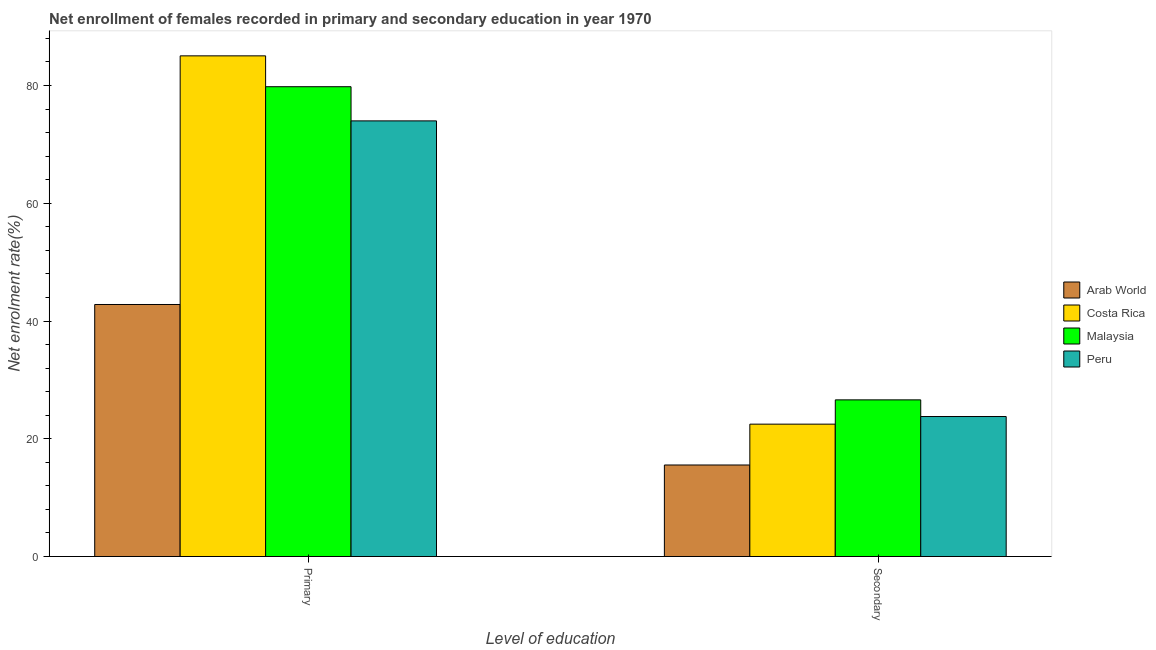How many different coloured bars are there?
Provide a short and direct response. 4. How many groups of bars are there?
Make the answer very short. 2. Are the number of bars per tick equal to the number of legend labels?
Offer a very short reply. Yes. Are the number of bars on each tick of the X-axis equal?
Keep it short and to the point. Yes. How many bars are there on the 2nd tick from the left?
Provide a succinct answer. 4. How many bars are there on the 2nd tick from the right?
Keep it short and to the point. 4. What is the label of the 2nd group of bars from the left?
Your answer should be compact. Secondary. What is the enrollment rate in secondary education in Peru?
Offer a very short reply. 23.78. Across all countries, what is the maximum enrollment rate in primary education?
Keep it short and to the point. 85.03. Across all countries, what is the minimum enrollment rate in primary education?
Keep it short and to the point. 42.8. In which country was the enrollment rate in secondary education maximum?
Keep it short and to the point. Malaysia. In which country was the enrollment rate in primary education minimum?
Offer a very short reply. Arab World. What is the total enrollment rate in secondary education in the graph?
Offer a terse response. 88.41. What is the difference between the enrollment rate in primary education in Peru and that in Malaysia?
Keep it short and to the point. -5.8. What is the difference between the enrollment rate in primary education in Malaysia and the enrollment rate in secondary education in Peru?
Your answer should be compact. 56.01. What is the average enrollment rate in secondary education per country?
Provide a succinct answer. 22.1. What is the difference between the enrollment rate in primary education and enrollment rate in secondary education in Costa Rica?
Your response must be concise. 62.55. In how many countries, is the enrollment rate in primary education greater than 8 %?
Provide a short and direct response. 4. What is the ratio of the enrollment rate in primary education in Malaysia to that in Arab World?
Your answer should be very brief. 1.86. Is the enrollment rate in secondary education in Malaysia less than that in Arab World?
Make the answer very short. No. What does the 2nd bar from the right in Secondary represents?
Your answer should be compact. Malaysia. Does the graph contain any zero values?
Make the answer very short. No. How many legend labels are there?
Make the answer very short. 4. What is the title of the graph?
Your answer should be compact. Net enrollment of females recorded in primary and secondary education in year 1970. Does "Andorra" appear as one of the legend labels in the graph?
Make the answer very short. No. What is the label or title of the X-axis?
Your answer should be compact. Level of education. What is the label or title of the Y-axis?
Provide a short and direct response. Net enrolment rate(%). What is the Net enrolment rate(%) in Arab World in Primary?
Your response must be concise. 42.8. What is the Net enrolment rate(%) of Costa Rica in Primary?
Your answer should be very brief. 85.03. What is the Net enrolment rate(%) in Malaysia in Primary?
Make the answer very short. 79.79. What is the Net enrolment rate(%) of Peru in Primary?
Your answer should be very brief. 73.99. What is the Net enrolment rate(%) in Arab World in Secondary?
Give a very brief answer. 15.54. What is the Net enrolment rate(%) of Costa Rica in Secondary?
Your response must be concise. 22.48. What is the Net enrolment rate(%) of Malaysia in Secondary?
Provide a succinct answer. 26.61. What is the Net enrolment rate(%) in Peru in Secondary?
Offer a very short reply. 23.78. Across all Level of education, what is the maximum Net enrolment rate(%) of Arab World?
Offer a terse response. 42.8. Across all Level of education, what is the maximum Net enrolment rate(%) of Costa Rica?
Your answer should be very brief. 85.03. Across all Level of education, what is the maximum Net enrolment rate(%) of Malaysia?
Provide a succinct answer. 79.79. Across all Level of education, what is the maximum Net enrolment rate(%) of Peru?
Your response must be concise. 73.99. Across all Level of education, what is the minimum Net enrolment rate(%) of Arab World?
Offer a terse response. 15.54. Across all Level of education, what is the minimum Net enrolment rate(%) of Costa Rica?
Your response must be concise. 22.48. Across all Level of education, what is the minimum Net enrolment rate(%) of Malaysia?
Make the answer very short. 26.61. Across all Level of education, what is the minimum Net enrolment rate(%) in Peru?
Give a very brief answer. 23.78. What is the total Net enrolment rate(%) in Arab World in the graph?
Keep it short and to the point. 58.35. What is the total Net enrolment rate(%) of Costa Rica in the graph?
Give a very brief answer. 107.51. What is the total Net enrolment rate(%) in Malaysia in the graph?
Give a very brief answer. 106.4. What is the total Net enrolment rate(%) in Peru in the graph?
Keep it short and to the point. 97.77. What is the difference between the Net enrolment rate(%) in Arab World in Primary and that in Secondary?
Provide a short and direct response. 27.26. What is the difference between the Net enrolment rate(%) of Costa Rica in Primary and that in Secondary?
Your response must be concise. 62.55. What is the difference between the Net enrolment rate(%) of Malaysia in Primary and that in Secondary?
Your answer should be compact. 53.18. What is the difference between the Net enrolment rate(%) of Peru in Primary and that in Secondary?
Your answer should be compact. 50.21. What is the difference between the Net enrolment rate(%) in Arab World in Primary and the Net enrolment rate(%) in Costa Rica in Secondary?
Offer a terse response. 20.32. What is the difference between the Net enrolment rate(%) of Arab World in Primary and the Net enrolment rate(%) of Malaysia in Secondary?
Give a very brief answer. 16.2. What is the difference between the Net enrolment rate(%) of Arab World in Primary and the Net enrolment rate(%) of Peru in Secondary?
Provide a short and direct response. 19.03. What is the difference between the Net enrolment rate(%) in Costa Rica in Primary and the Net enrolment rate(%) in Malaysia in Secondary?
Ensure brevity in your answer.  58.42. What is the difference between the Net enrolment rate(%) of Costa Rica in Primary and the Net enrolment rate(%) of Peru in Secondary?
Give a very brief answer. 61.25. What is the difference between the Net enrolment rate(%) in Malaysia in Primary and the Net enrolment rate(%) in Peru in Secondary?
Ensure brevity in your answer.  56.01. What is the average Net enrolment rate(%) of Arab World per Level of education?
Your answer should be very brief. 29.17. What is the average Net enrolment rate(%) in Costa Rica per Level of education?
Provide a short and direct response. 53.76. What is the average Net enrolment rate(%) of Malaysia per Level of education?
Make the answer very short. 53.2. What is the average Net enrolment rate(%) in Peru per Level of education?
Offer a very short reply. 48.88. What is the difference between the Net enrolment rate(%) in Arab World and Net enrolment rate(%) in Costa Rica in Primary?
Give a very brief answer. -42.23. What is the difference between the Net enrolment rate(%) in Arab World and Net enrolment rate(%) in Malaysia in Primary?
Your answer should be compact. -36.99. What is the difference between the Net enrolment rate(%) in Arab World and Net enrolment rate(%) in Peru in Primary?
Offer a terse response. -31.18. What is the difference between the Net enrolment rate(%) in Costa Rica and Net enrolment rate(%) in Malaysia in Primary?
Ensure brevity in your answer.  5.24. What is the difference between the Net enrolment rate(%) in Costa Rica and Net enrolment rate(%) in Peru in Primary?
Your answer should be very brief. 11.04. What is the difference between the Net enrolment rate(%) of Malaysia and Net enrolment rate(%) of Peru in Primary?
Ensure brevity in your answer.  5.8. What is the difference between the Net enrolment rate(%) of Arab World and Net enrolment rate(%) of Costa Rica in Secondary?
Offer a very short reply. -6.94. What is the difference between the Net enrolment rate(%) of Arab World and Net enrolment rate(%) of Malaysia in Secondary?
Your answer should be very brief. -11.06. What is the difference between the Net enrolment rate(%) of Arab World and Net enrolment rate(%) of Peru in Secondary?
Your response must be concise. -8.23. What is the difference between the Net enrolment rate(%) in Costa Rica and Net enrolment rate(%) in Malaysia in Secondary?
Your answer should be compact. -4.12. What is the difference between the Net enrolment rate(%) in Costa Rica and Net enrolment rate(%) in Peru in Secondary?
Your response must be concise. -1.3. What is the difference between the Net enrolment rate(%) in Malaysia and Net enrolment rate(%) in Peru in Secondary?
Offer a very short reply. 2.83. What is the ratio of the Net enrolment rate(%) in Arab World in Primary to that in Secondary?
Your answer should be very brief. 2.75. What is the ratio of the Net enrolment rate(%) of Costa Rica in Primary to that in Secondary?
Keep it short and to the point. 3.78. What is the ratio of the Net enrolment rate(%) in Malaysia in Primary to that in Secondary?
Make the answer very short. 3. What is the ratio of the Net enrolment rate(%) of Peru in Primary to that in Secondary?
Give a very brief answer. 3.11. What is the difference between the highest and the second highest Net enrolment rate(%) in Arab World?
Give a very brief answer. 27.26. What is the difference between the highest and the second highest Net enrolment rate(%) of Costa Rica?
Give a very brief answer. 62.55. What is the difference between the highest and the second highest Net enrolment rate(%) of Malaysia?
Offer a very short reply. 53.18. What is the difference between the highest and the second highest Net enrolment rate(%) in Peru?
Ensure brevity in your answer.  50.21. What is the difference between the highest and the lowest Net enrolment rate(%) of Arab World?
Offer a very short reply. 27.26. What is the difference between the highest and the lowest Net enrolment rate(%) in Costa Rica?
Your answer should be compact. 62.55. What is the difference between the highest and the lowest Net enrolment rate(%) of Malaysia?
Provide a short and direct response. 53.18. What is the difference between the highest and the lowest Net enrolment rate(%) in Peru?
Keep it short and to the point. 50.21. 